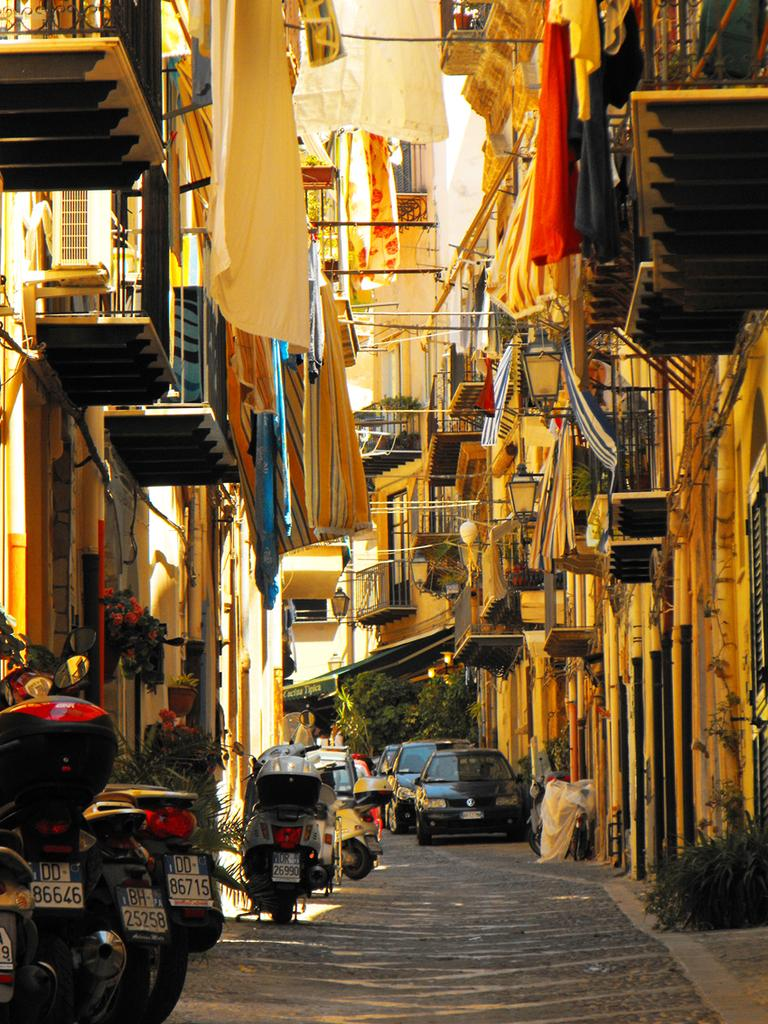What type of structures can be seen in the image? There are buildings in the image. What is attached to the buildings? Objects are attached to the buildings. What are the poles in the image used for? The poles in the image are likely used for support or as markers. What is hanging on the clothesline in the image? Clothes are visible in the image. What type of barrier is present in the image? There is fencing in the image. What can be used for walking or traveling in the image? There is a path in the image. What type of transportation is visible in the image? Vehicles are present in the image. What is used for illumination in the image? Lights are present in the image. What type of vegetation is visible in the image? Plants are visible in the image. How many cows are laughing on the path in the image? There are no cows present in the image, and therefore no such activity can be observed. 